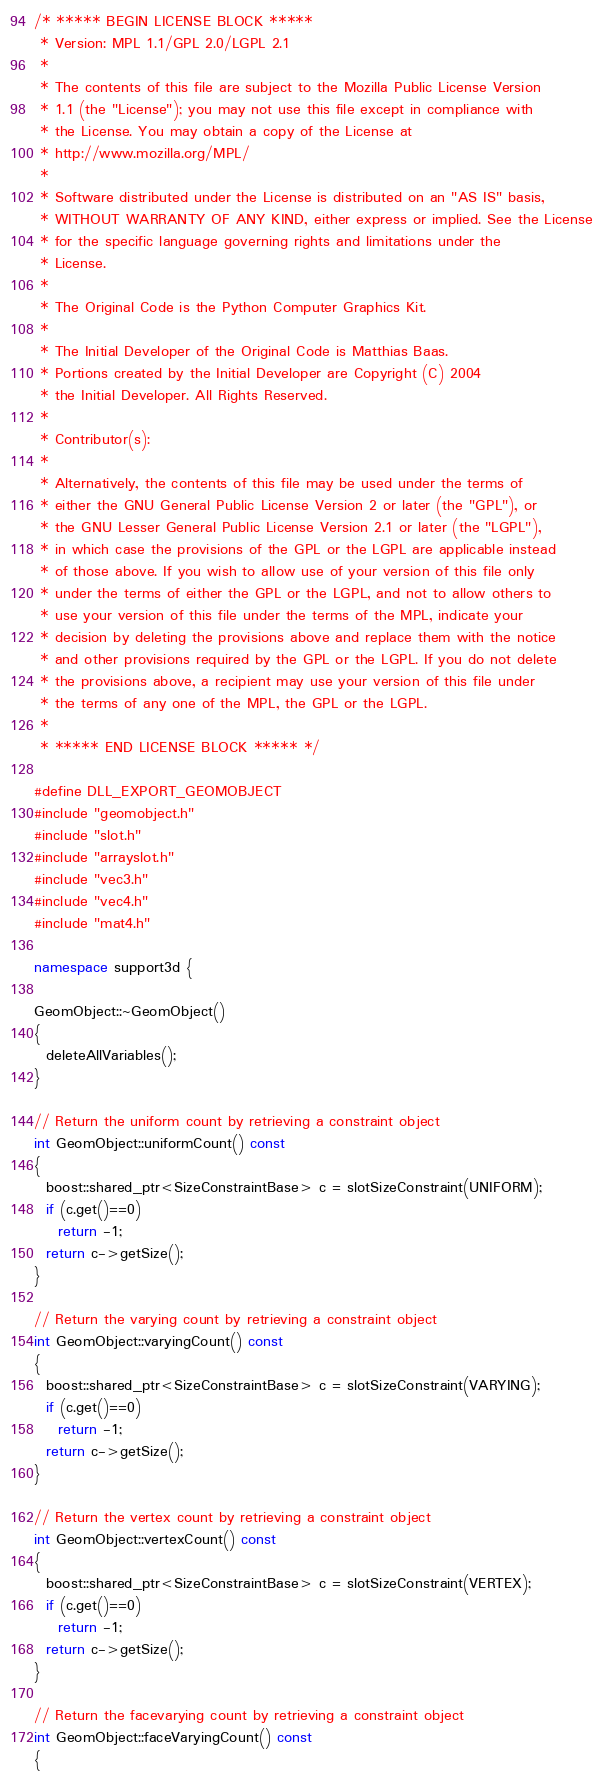<code> <loc_0><loc_0><loc_500><loc_500><_C++_>/* ***** BEGIN LICENSE BLOCK *****
 * Version: MPL 1.1/GPL 2.0/LGPL 2.1
 *
 * The contents of this file are subject to the Mozilla Public License Version
 * 1.1 (the "License"); you may not use this file except in compliance with
 * the License. You may obtain a copy of the License at
 * http://www.mozilla.org/MPL/
 *
 * Software distributed under the License is distributed on an "AS IS" basis,
 * WITHOUT WARRANTY OF ANY KIND, either express or implied. See the License
 * for the specific language governing rights and limitations under the
 * License.
 *
 * The Original Code is the Python Computer Graphics Kit.
 *
 * The Initial Developer of the Original Code is Matthias Baas.
 * Portions created by the Initial Developer are Copyright (C) 2004
 * the Initial Developer. All Rights Reserved.
 *
 * Contributor(s):
 *
 * Alternatively, the contents of this file may be used under the terms of
 * either the GNU General Public License Version 2 or later (the "GPL"), or
 * the GNU Lesser General Public License Version 2.1 or later (the "LGPL"),
 * in which case the provisions of the GPL or the LGPL are applicable instead
 * of those above. If you wish to allow use of your version of this file only
 * under the terms of either the GPL or the LGPL, and not to allow others to
 * use your version of this file under the terms of the MPL, indicate your
 * decision by deleting the provisions above and replace them with the notice
 * and other provisions required by the GPL or the LGPL. If you do not delete
 * the provisions above, a recipient may use your version of this file under
 * the terms of any one of the MPL, the GPL or the LGPL.
 *
 * ***** END LICENSE BLOCK ***** */

#define DLL_EXPORT_GEOMOBJECT
#include "geomobject.h"
#include "slot.h"
#include "arrayslot.h"
#include "vec3.h"
#include "vec4.h"
#include "mat4.h"

namespace support3d {

GeomObject::~GeomObject()
{
  deleteAllVariables();
}

// Return the uniform count by retrieving a constraint object
int GeomObject::uniformCount() const
{
  boost::shared_ptr<SizeConstraintBase> c = slotSizeConstraint(UNIFORM);
  if (c.get()==0)
    return -1;
  return c->getSize(); 
}

// Return the varying count by retrieving a constraint object
int GeomObject::varyingCount() const
{
  boost::shared_ptr<SizeConstraintBase> c = slotSizeConstraint(VARYING);
  if (c.get()==0)
    return -1;
  return c->getSize(); 
}

// Return the vertex count by retrieving a constraint object
int GeomObject::vertexCount() const
{
  boost::shared_ptr<SizeConstraintBase> c = slotSizeConstraint(VERTEX);
  if (c.get()==0)
    return -1;
  return c->getSize(); 
}

// Return the facevarying count by retrieving a constraint object
int GeomObject::faceVaryingCount() const
{</code> 